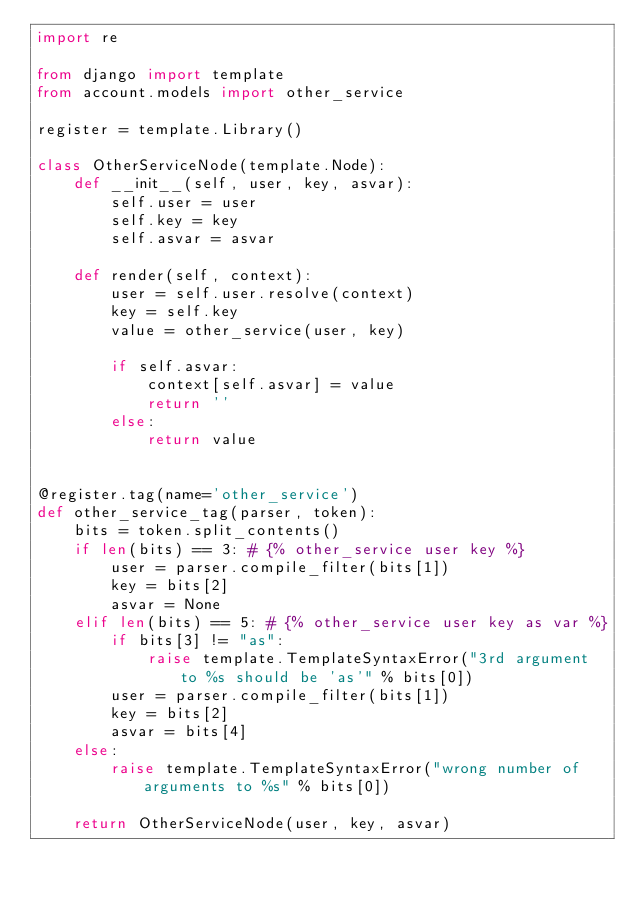Convert code to text. <code><loc_0><loc_0><loc_500><loc_500><_Python_>import re

from django import template
from account.models import other_service

register = template.Library()

class OtherServiceNode(template.Node):
    def __init__(self, user, key, asvar):
        self.user = user
        self.key = key
        self.asvar = asvar
    
    def render(self, context):
        user = self.user.resolve(context)
        key = self.key
        value = other_service(user, key)
                    
        if self.asvar:
            context[self.asvar] = value
            return ''
        else:
            return value


@register.tag(name='other_service')
def other_service_tag(parser, token):
    bits = token.split_contents()
    if len(bits) == 3: # {% other_service user key %}
        user = parser.compile_filter(bits[1])
        key = bits[2]
        asvar = None
    elif len(bits) == 5: # {% other_service user key as var %}
        if bits[3] != "as":
            raise template.TemplateSyntaxError("3rd argument to %s should be 'as'" % bits[0])
        user = parser.compile_filter(bits[1])
        key = bits[2]
        asvar = bits[4]
    else:
        raise template.TemplateSyntaxError("wrong number of arguments to %s" % bits[0])
    
    return OtherServiceNode(user, key, asvar)
</code> 